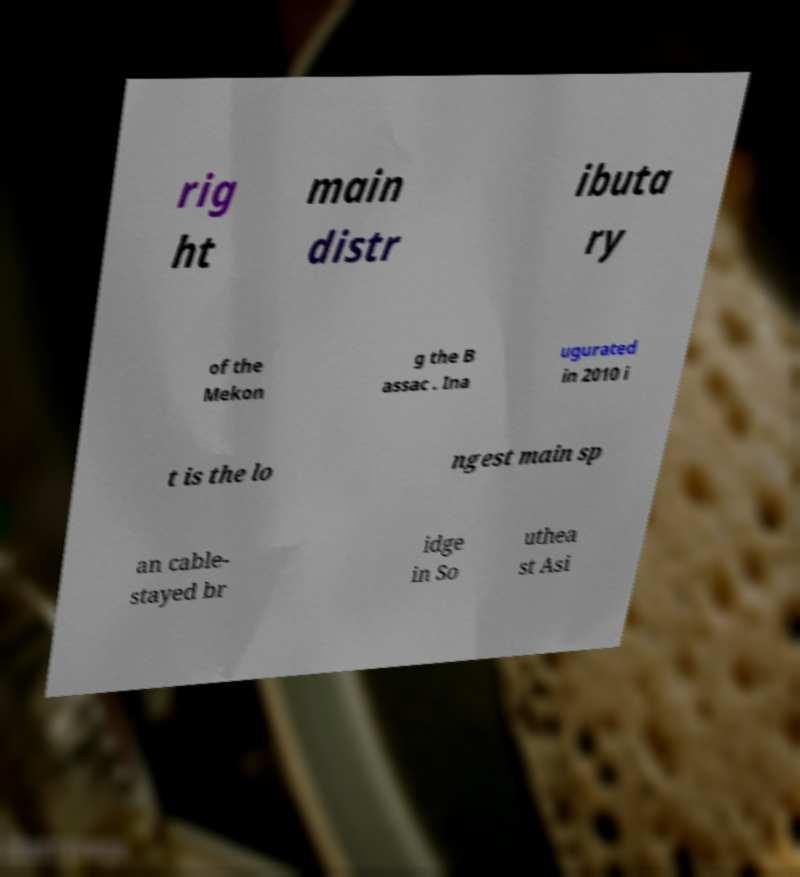I need the written content from this picture converted into text. Can you do that? rig ht main distr ibuta ry of the Mekon g the B assac . Ina ugurated in 2010 i t is the lo ngest main sp an cable- stayed br idge in So uthea st Asi 